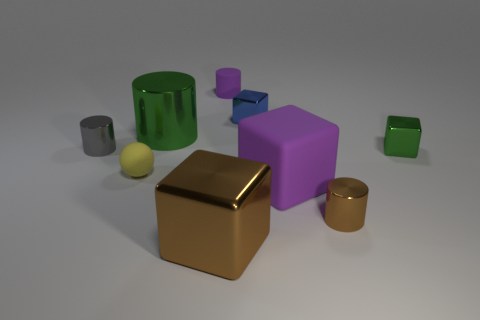There is a rubber object right of the purple rubber object that is behind the small yellow ball; what is its shape?
Provide a succinct answer. Cube. How many small red spheres have the same material as the tiny yellow sphere?
Your response must be concise. 0. What material is the purple object in front of the tiny green block?
Make the answer very short. Rubber. The brown thing that is on the right side of the big object in front of the tiny brown metal cylinder to the right of the tiny matte ball is what shape?
Offer a terse response. Cylinder. Does the metal cube that is behind the green block have the same color as the tiny cylinder that is to the right of the purple rubber cylinder?
Your answer should be very brief. No. Is the number of small metal things that are to the right of the small green metal thing less than the number of rubber objects that are behind the blue metal block?
Offer a terse response. Yes. Is there anything else that is the same shape as the small blue metal thing?
Offer a very short reply. Yes. What color is the large thing that is the same shape as the tiny purple object?
Your answer should be very brief. Green. Do the big rubber thing and the brown metallic thing left of the purple matte cylinder have the same shape?
Your answer should be very brief. Yes. What number of things are either big cubes that are behind the big brown cube or shiny cylinders to the left of the small brown thing?
Offer a terse response. 3. 